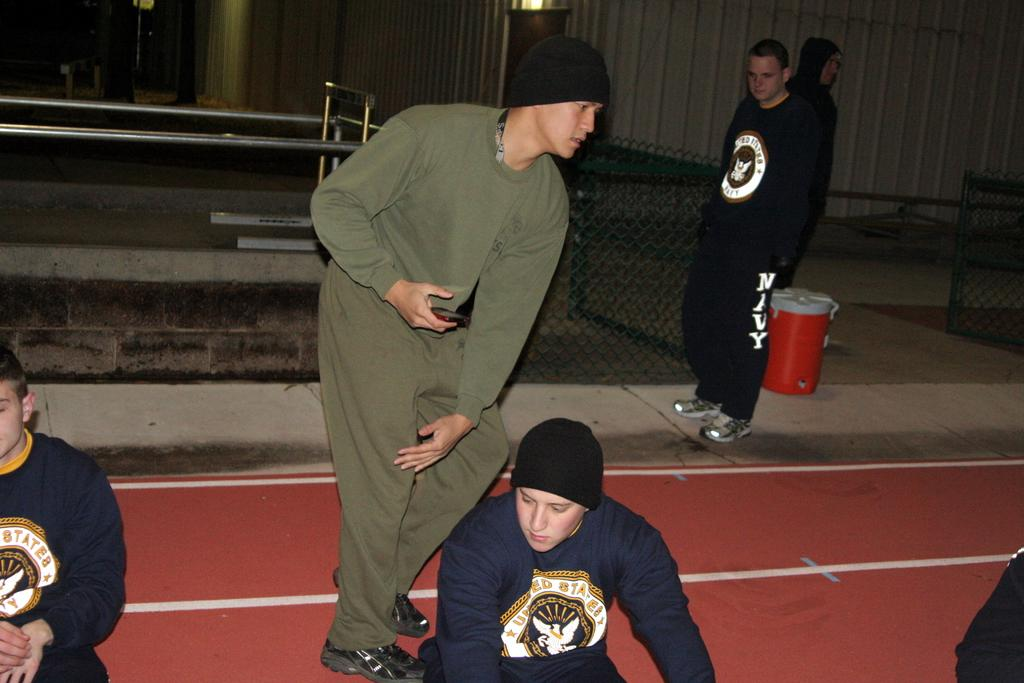<image>
Share a concise interpretation of the image provided. the men in black are wearing United States Navy clothing 